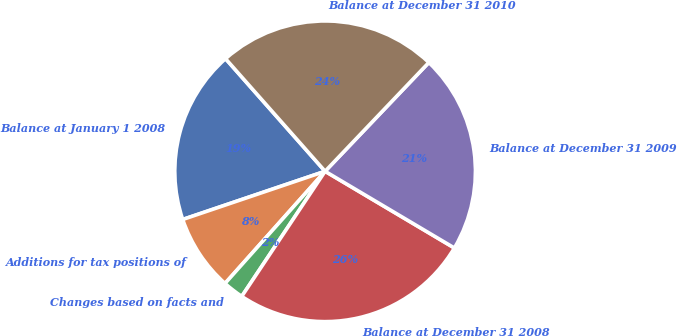<chart> <loc_0><loc_0><loc_500><loc_500><pie_chart><fcel>Balance at January 1 2008<fcel>Additions for tax positions of<fcel>Changes based on facts and<fcel>Balance at December 31 2008<fcel>Balance at December 31 2009<fcel>Balance at December 31 2010<nl><fcel>18.67%<fcel>8.21%<fcel>2.24%<fcel>25.83%<fcel>21.4%<fcel>23.64%<nl></chart> 